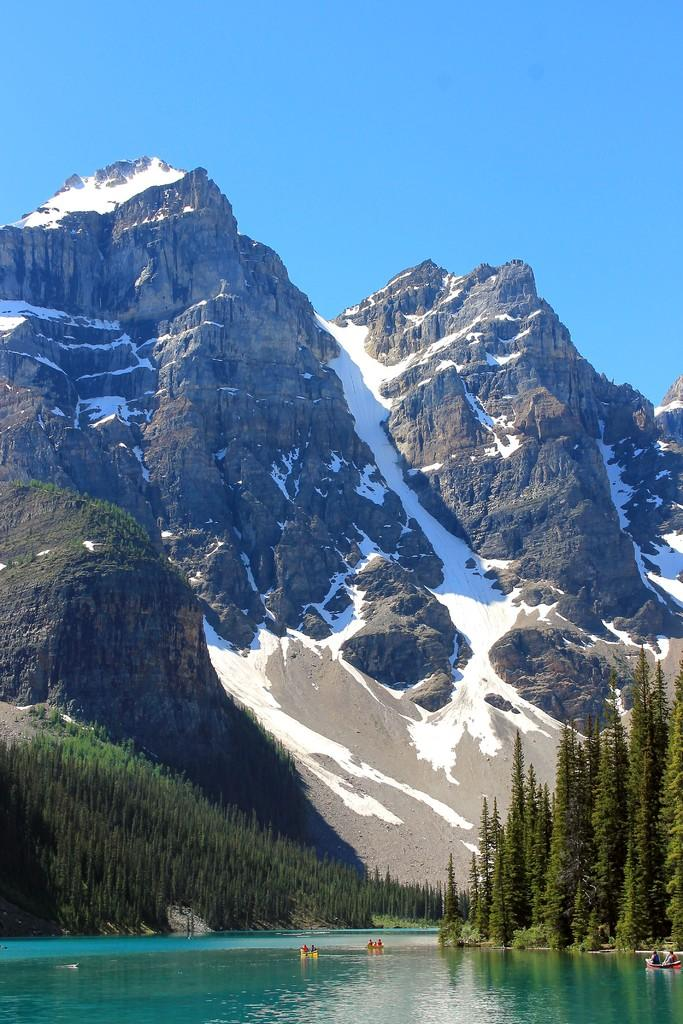What can be seen in the background of the image? The sky is visible in the background of the image. What is the weather like on the day the image was taken? It appears to be a sunny day. What type of landscape is featured in the image? There are hills in the image. What type of vegetation is present in the image? Trees are present in the image. What body of water is visible in the image? There is water visible in the image. What type of vehicles are in the image? Boats are in the image. Are there any people present in the image? Yes, people are in the image. How does the comparison between the two days in the image affect the outcome of the race? There is no race or comparison between two days present in the image. 